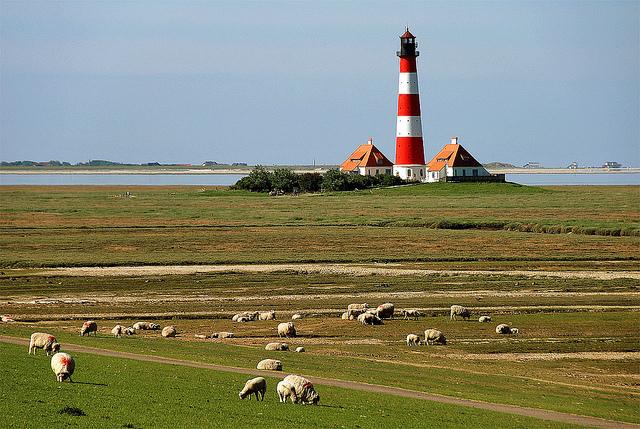Have the sheep been recently sheared?
Give a very brief answer. No. What are the colors of the lighthouse?
Quick response, please. Red and white. What are the sheep doing?
Quick response, please. Grazing. 